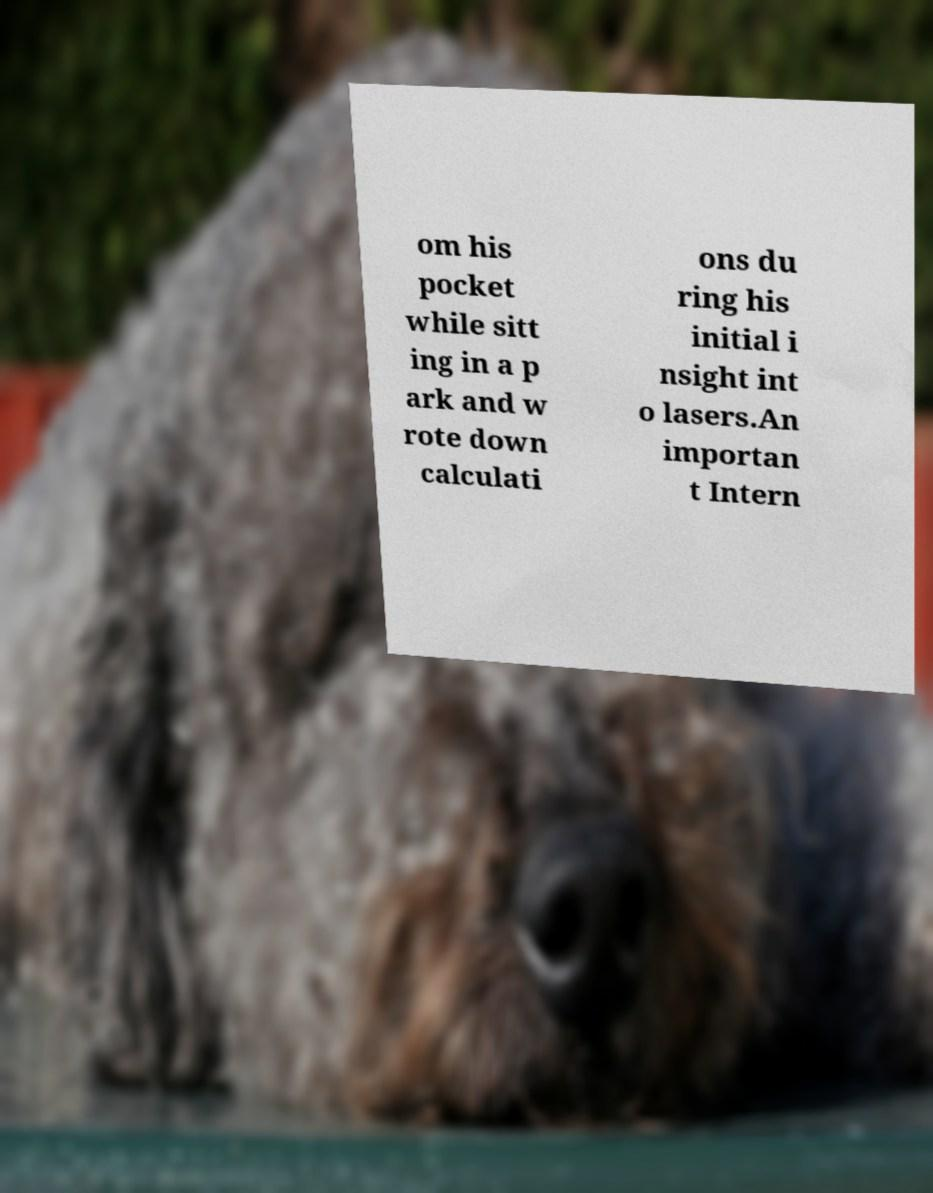Could you assist in decoding the text presented in this image and type it out clearly? om his pocket while sitt ing in a p ark and w rote down calculati ons du ring his initial i nsight int o lasers.An importan t Intern 